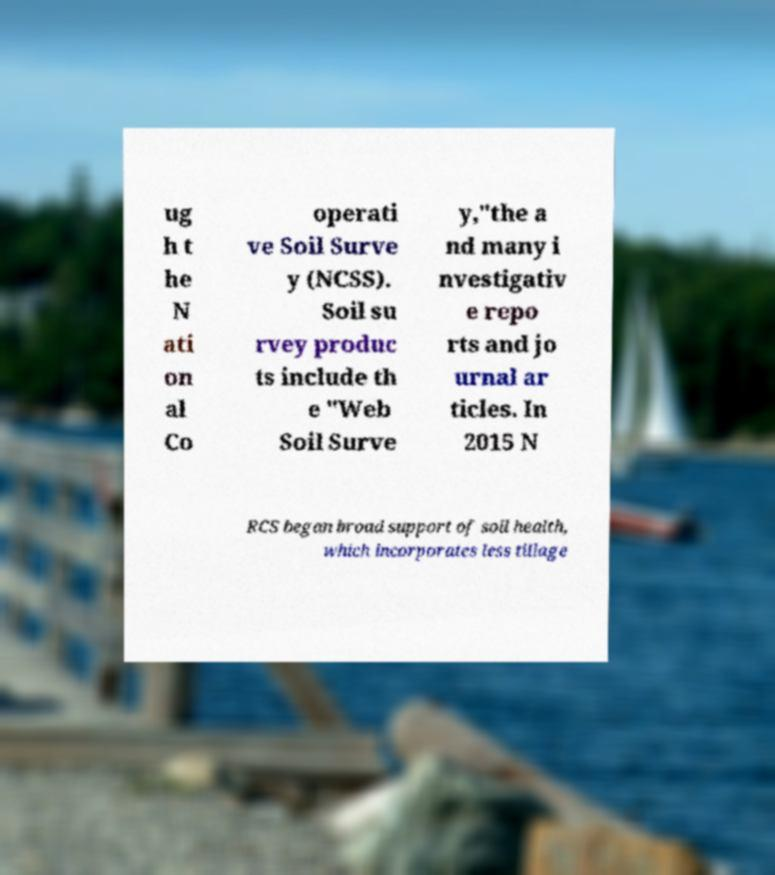Can you read and provide the text displayed in the image?This photo seems to have some interesting text. Can you extract and type it out for me? ug h t he N ati on al Co operati ve Soil Surve y (NCSS). Soil su rvey produc ts include th e "Web Soil Surve y,"the a nd many i nvestigativ e repo rts and jo urnal ar ticles. In 2015 N RCS began broad support of soil health, which incorporates less tillage 